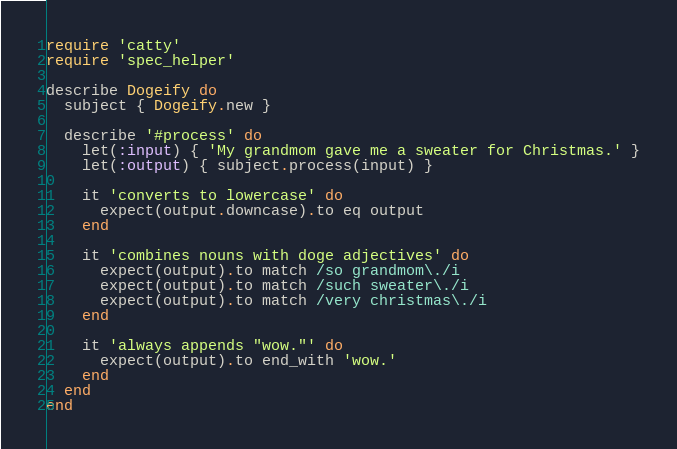<code> <loc_0><loc_0><loc_500><loc_500><_Ruby_>require 'catty'
require 'spec_helper'

describe Dogeify do
  subject { Dogeify.new }

  describe '#process' do
    let(:input) { 'My grandmom gave me a sweater for Christmas.' }
    let(:output) { subject.process(input) }

    it 'converts to lowercase' do
      expect(output.downcase).to eq output
    end

    it 'combines nouns with doge adjectives' do
      expect(output).to match /so grandmom\./i
      expect(output).to match /such sweater\./i
      expect(output).to match /very christmas\./i
    end

    it 'always appends "wow."' do
      expect(output).to end_with 'wow.'
    end
  end
end</code> 